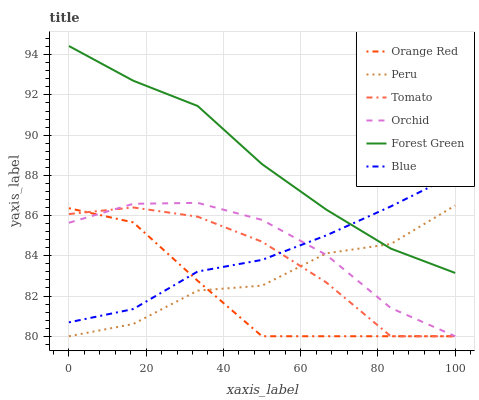Does Orange Red have the minimum area under the curve?
Answer yes or no. Yes. Does Forest Green have the maximum area under the curve?
Answer yes or no. Yes. Does Blue have the minimum area under the curve?
Answer yes or no. No. Does Blue have the maximum area under the curve?
Answer yes or no. No. Is Blue the smoothest?
Answer yes or no. Yes. Is Peru the roughest?
Answer yes or no. Yes. Is Forest Green the smoothest?
Answer yes or no. No. Is Forest Green the roughest?
Answer yes or no. No. Does Tomato have the lowest value?
Answer yes or no. Yes. Does Blue have the lowest value?
Answer yes or no. No. Does Forest Green have the highest value?
Answer yes or no. Yes. Does Blue have the highest value?
Answer yes or no. No. Is Orange Red less than Forest Green?
Answer yes or no. Yes. Is Blue greater than Peru?
Answer yes or no. Yes. Does Blue intersect Forest Green?
Answer yes or no. Yes. Is Blue less than Forest Green?
Answer yes or no. No. Is Blue greater than Forest Green?
Answer yes or no. No. Does Orange Red intersect Forest Green?
Answer yes or no. No. 